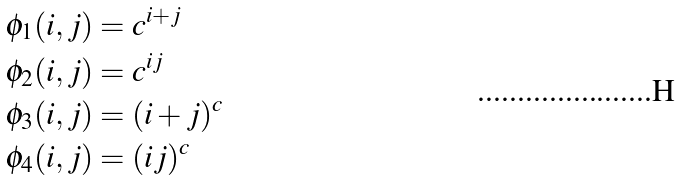Convert formula to latex. <formula><loc_0><loc_0><loc_500><loc_500>\phi _ { 1 } ( i , j ) & = c ^ { i + j } \\ \phi _ { 2 } ( i , j ) & = c ^ { i j } \\ \phi _ { 3 } ( i , j ) & = ( i + j ) ^ { c } \\ \phi _ { 4 } ( i , j ) & = ( i j ) ^ { c }</formula> 